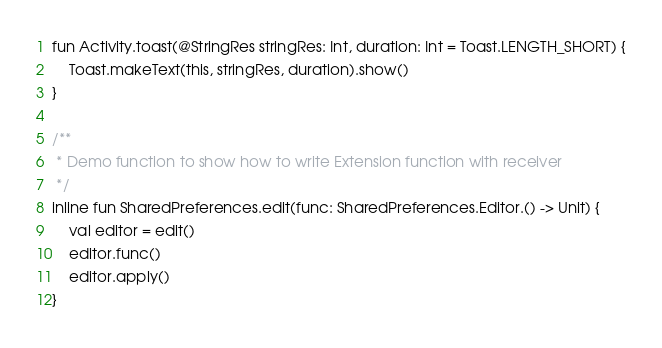Convert code to text. <code><loc_0><loc_0><loc_500><loc_500><_Kotlin_>fun Activity.toast(@StringRes stringRes: Int, duration: Int = Toast.LENGTH_SHORT) {
    Toast.makeText(this, stringRes, duration).show()
}

/**
 * Demo function to show how to write Extension function with receiver
 */
inline fun SharedPreferences.edit(func: SharedPreferences.Editor.() -> Unit) {
    val editor = edit()
    editor.func()
    editor.apply()
}</code> 